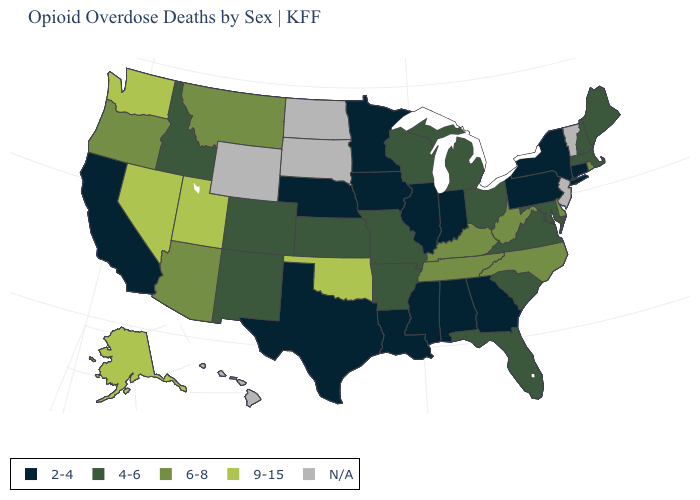What is the value of West Virginia?
Quick response, please. 6-8. What is the value of Oklahoma?
Give a very brief answer. 9-15. What is the lowest value in the USA?
Quick response, please. 2-4. What is the value of Delaware?
Concise answer only. 6-8. What is the highest value in the MidWest ?
Keep it brief. 4-6. Name the states that have a value in the range 6-8?
Give a very brief answer. Arizona, Delaware, Kentucky, Montana, North Carolina, Oregon, Rhode Island, Tennessee, West Virginia. Which states have the highest value in the USA?
Concise answer only. Alaska, Nevada, Oklahoma, Utah, Washington. Name the states that have a value in the range 4-6?
Give a very brief answer. Arkansas, Colorado, Florida, Idaho, Kansas, Maine, Maryland, Massachusetts, Michigan, Missouri, New Hampshire, New Mexico, Ohio, South Carolina, Virginia, Wisconsin. What is the value of New York?
Quick response, please. 2-4. What is the highest value in the Northeast ?
Quick response, please. 6-8. What is the value of Wisconsin?
Keep it brief. 4-6. Name the states that have a value in the range N/A?
Keep it brief. Hawaii, New Jersey, North Dakota, South Dakota, Vermont, Wyoming. Name the states that have a value in the range 2-4?
Be succinct. Alabama, California, Connecticut, Georgia, Illinois, Indiana, Iowa, Louisiana, Minnesota, Mississippi, Nebraska, New York, Pennsylvania, Texas. Which states have the lowest value in the West?
Write a very short answer. California. Name the states that have a value in the range 9-15?
Quick response, please. Alaska, Nevada, Oklahoma, Utah, Washington. 